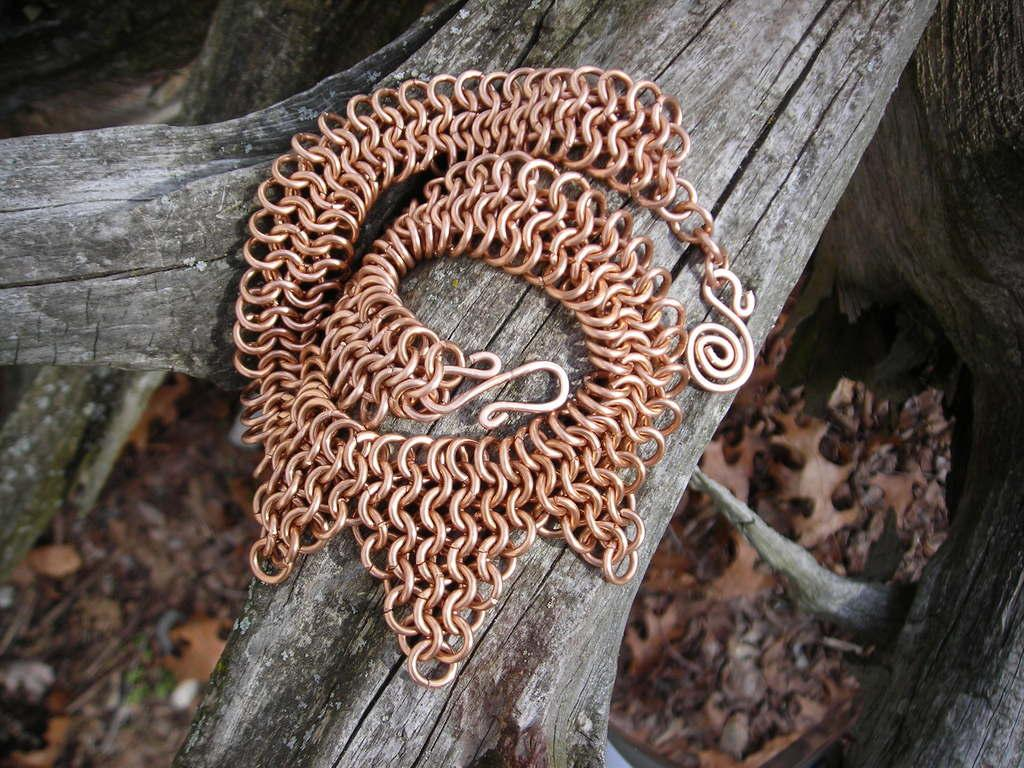What is attached to the wooden trunk in the image? There is a metal chain on a wooden trunk in the image. Can you describe the wooden trunks in the background? There are wooden trunks in the background of the image. What type of surface is visible in the background? The background of the image includes land. What type of shop can be seen in the image? There is no shop present in the image; it features a wooden trunk with a metal chain and a background that includes land. 